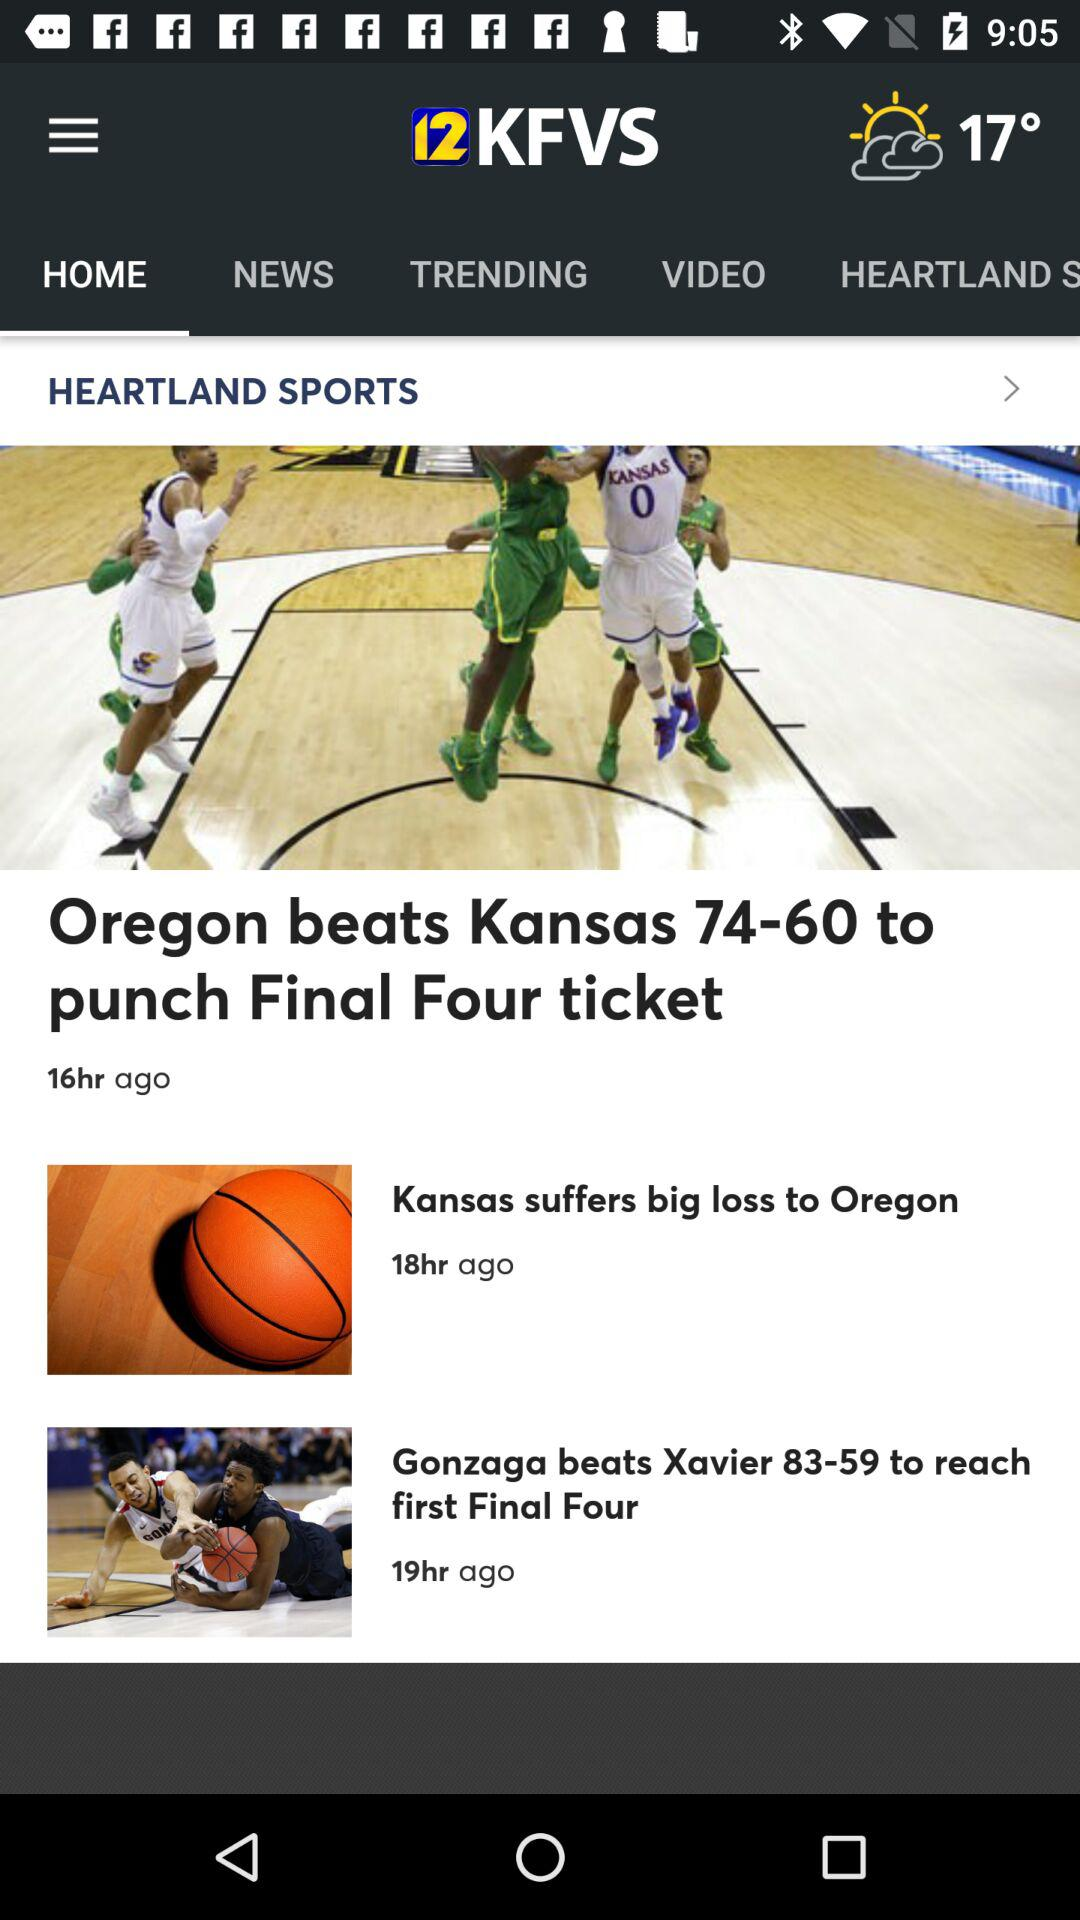Which tab is selected? The selected tab is "HOME". 